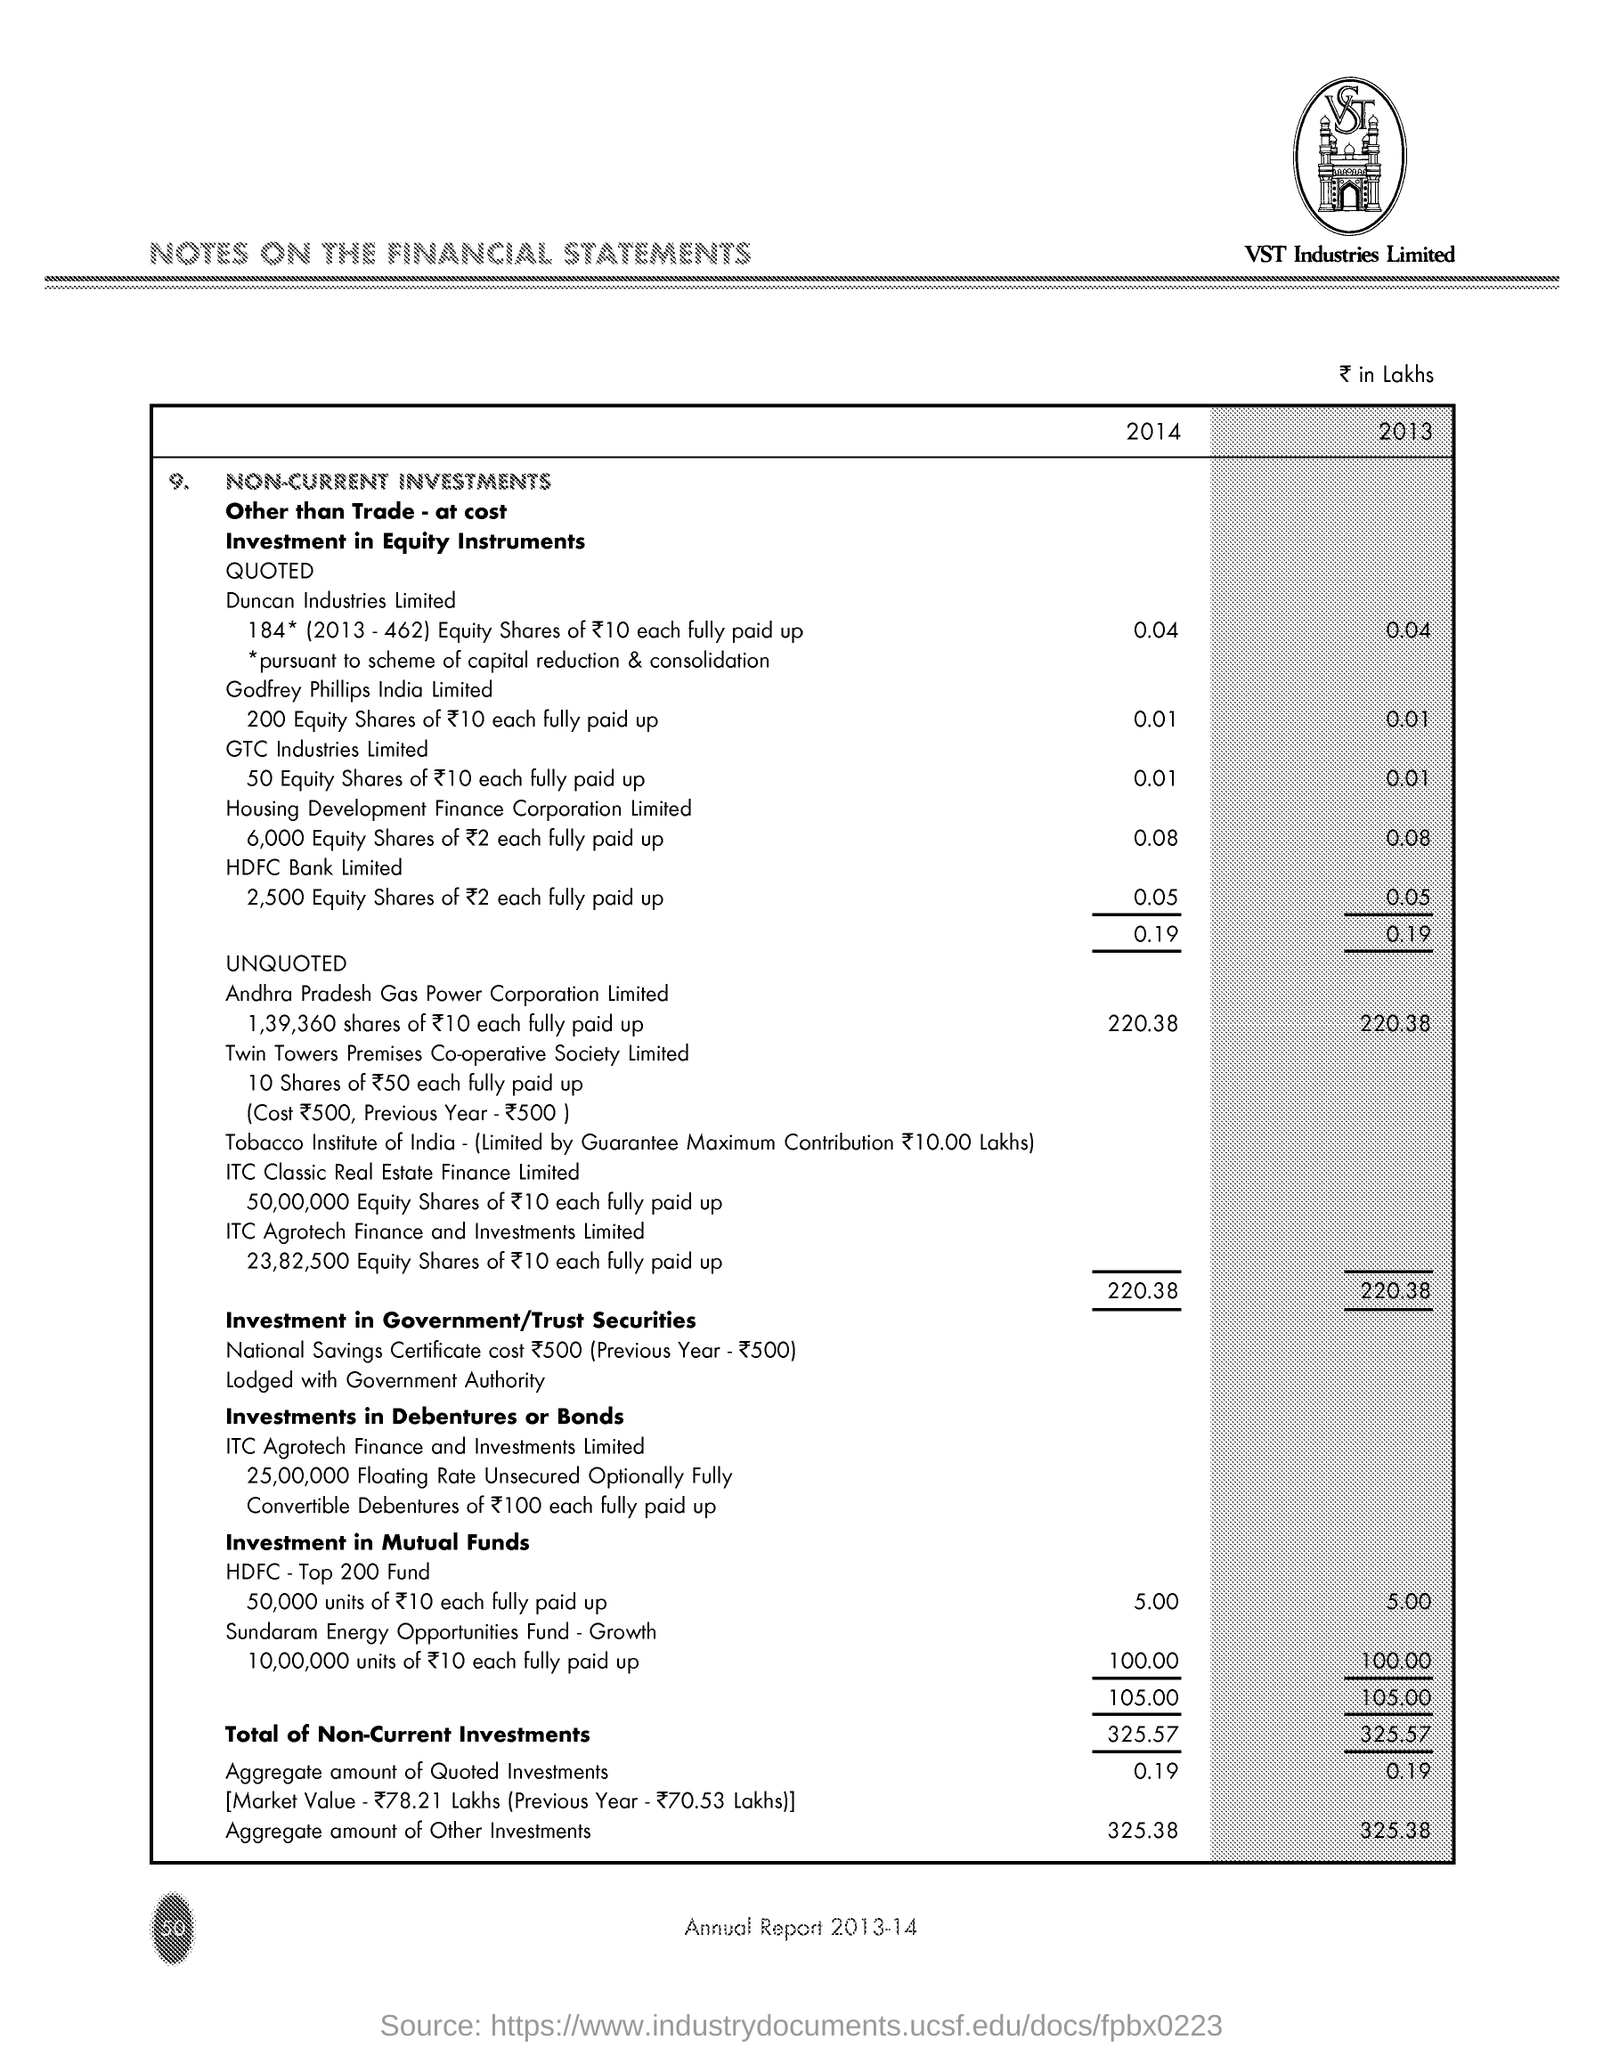What is the aggregate amount of other investments in 2014?
Offer a terse response. 325.38. What is the aggregate amount of quoted investments in 2013?
Ensure brevity in your answer.  0.19. What is written below the image?
Offer a terse response. VST Industries Limited. What is the title of the document?
Give a very brief answer. Notes on the financial statements. 